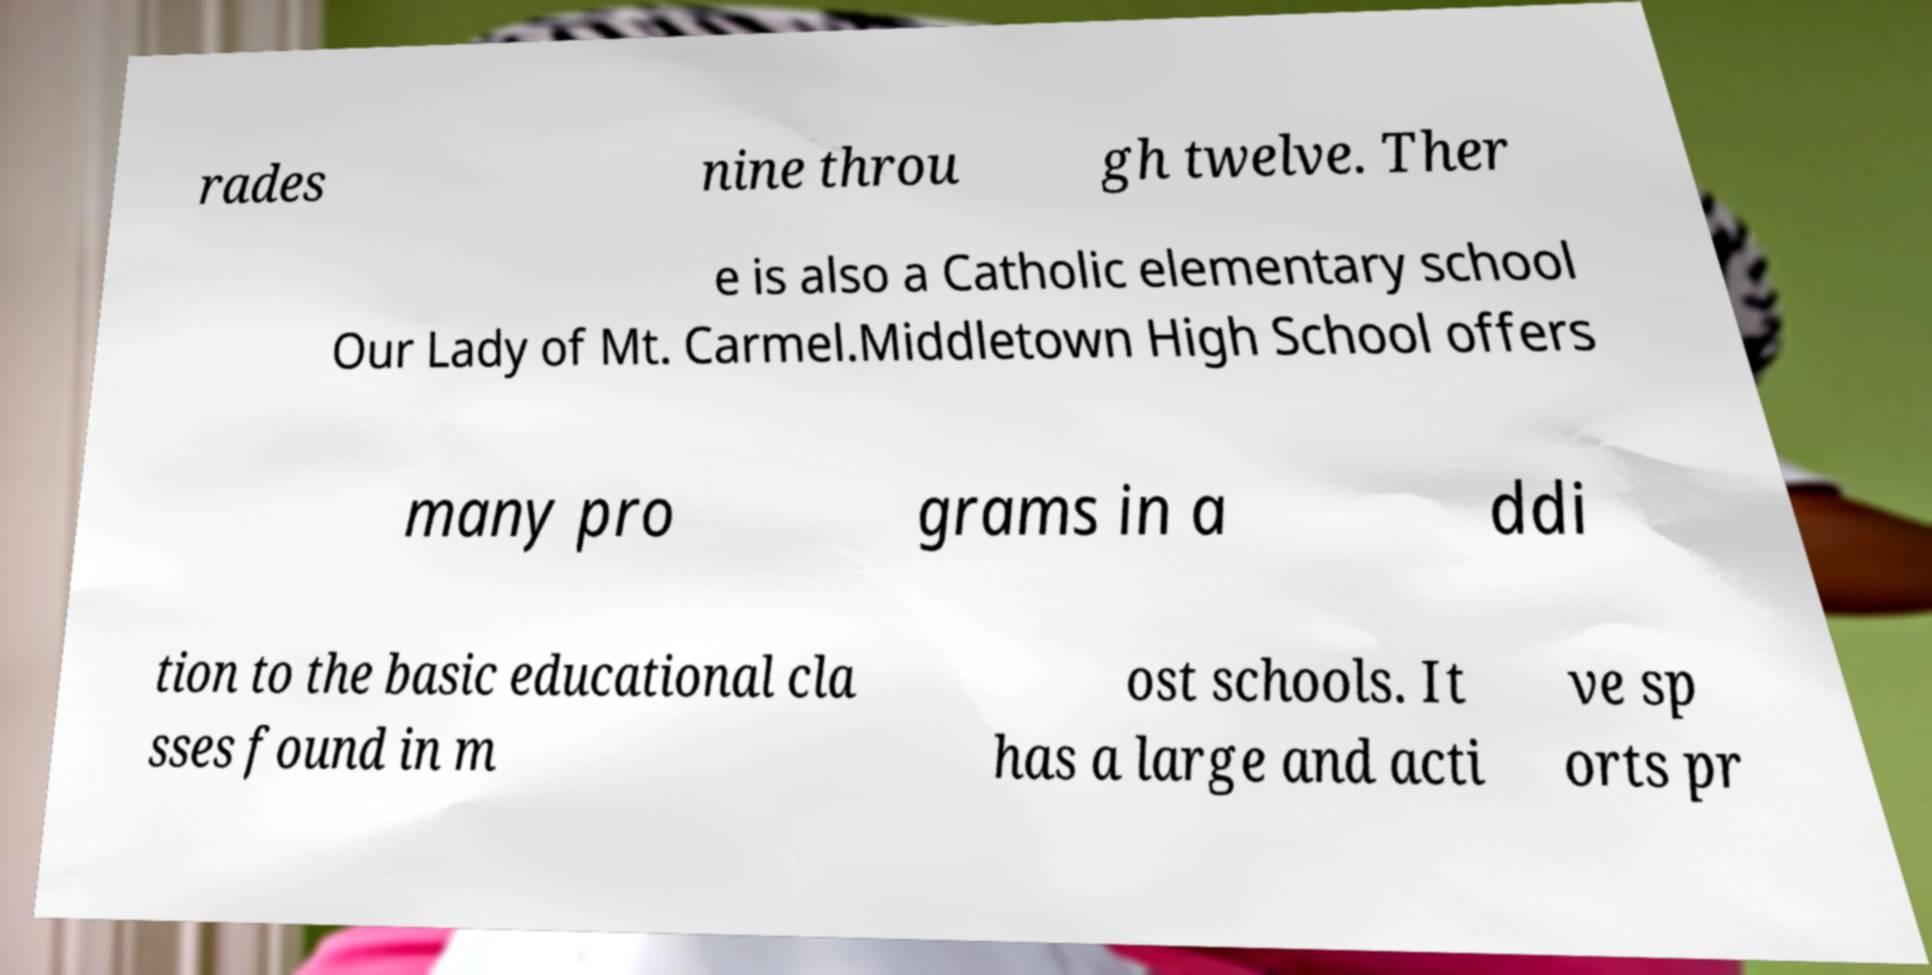There's text embedded in this image that I need extracted. Can you transcribe it verbatim? rades nine throu gh twelve. Ther e is also a Catholic elementary school Our Lady of Mt. Carmel.Middletown High School offers many pro grams in a ddi tion to the basic educational cla sses found in m ost schools. It has a large and acti ve sp orts pr 